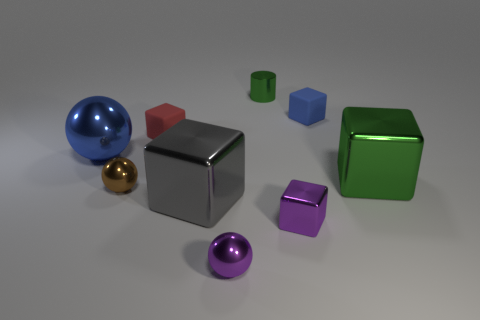What number of shiny things are there?
Keep it short and to the point. 7. There is a metallic sphere that is the same size as the brown shiny object; what is its color?
Your response must be concise. Purple. Is the material of the purple object in front of the purple shiny cube the same as the green object that is in front of the small blue block?
Your answer should be very brief. Yes. There is a purple object to the right of the green metal thing behind the blue metal thing; what size is it?
Give a very brief answer. Small. There is a tiny block left of the tiny purple metal sphere; what material is it?
Give a very brief answer. Rubber. What number of things are objects left of the large green thing or blue things that are in front of the small blue rubber block?
Make the answer very short. 8. There is a gray thing that is the same shape as the big green shiny object; what is it made of?
Make the answer very short. Metal. There is a matte thing behind the red cube; does it have the same color as the large block that is to the right of the tiny blue rubber cube?
Provide a succinct answer. No. Are there any gray metallic blocks that have the same size as the blue sphere?
Keep it short and to the point. Yes. There is a tiny object that is on the right side of the small green cylinder and in front of the tiny blue thing; what is its material?
Provide a short and direct response. Metal. 